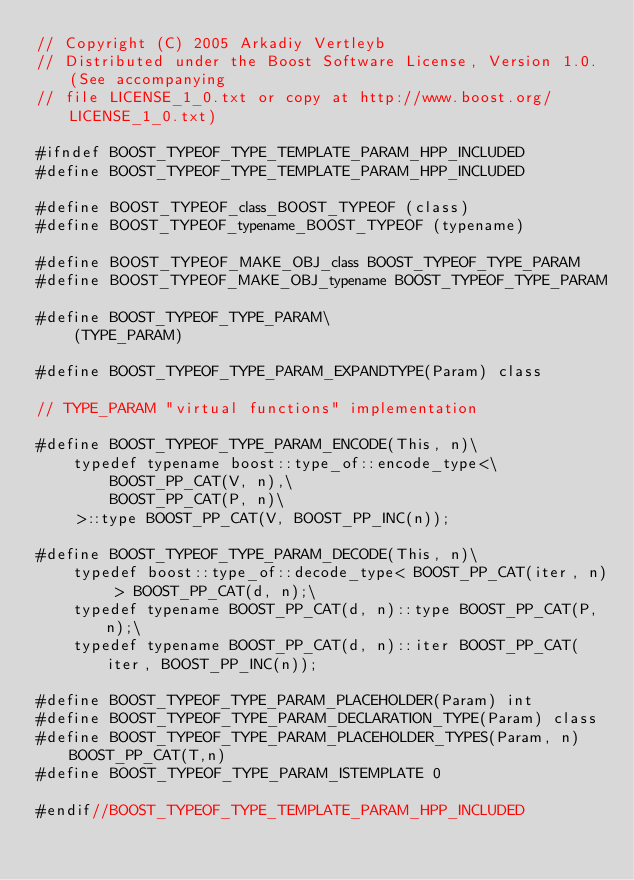<code> <loc_0><loc_0><loc_500><loc_500><_C++_>// Copyright (C) 2005 Arkadiy Vertleyb
// Distributed under the Boost Software License, Version 1.0. (See accompanying
// file LICENSE_1_0.txt or copy at http://www.boost.org/LICENSE_1_0.txt)

#ifndef BOOST_TYPEOF_TYPE_TEMPLATE_PARAM_HPP_INCLUDED
#define BOOST_TYPEOF_TYPE_TEMPLATE_PARAM_HPP_INCLUDED

#define BOOST_TYPEOF_class_BOOST_TYPEOF (class)
#define BOOST_TYPEOF_typename_BOOST_TYPEOF (typename)

#define BOOST_TYPEOF_MAKE_OBJ_class BOOST_TYPEOF_TYPE_PARAM
#define BOOST_TYPEOF_MAKE_OBJ_typename BOOST_TYPEOF_TYPE_PARAM

#define BOOST_TYPEOF_TYPE_PARAM\
    (TYPE_PARAM)

#define BOOST_TYPEOF_TYPE_PARAM_EXPANDTYPE(Param) class

// TYPE_PARAM "virtual functions" implementation

#define BOOST_TYPEOF_TYPE_PARAM_ENCODE(This, n)\
    typedef typename boost::type_of::encode_type<\
        BOOST_PP_CAT(V, n),\
        BOOST_PP_CAT(P, n)\
    >::type BOOST_PP_CAT(V, BOOST_PP_INC(n));

#define BOOST_TYPEOF_TYPE_PARAM_DECODE(This, n)\
    typedef boost::type_of::decode_type< BOOST_PP_CAT(iter, n) > BOOST_PP_CAT(d, n);\
    typedef typename BOOST_PP_CAT(d, n)::type BOOST_PP_CAT(P, n);\
    typedef typename BOOST_PP_CAT(d, n)::iter BOOST_PP_CAT(iter, BOOST_PP_INC(n));

#define BOOST_TYPEOF_TYPE_PARAM_PLACEHOLDER(Param) int
#define BOOST_TYPEOF_TYPE_PARAM_DECLARATION_TYPE(Param) class
#define BOOST_TYPEOF_TYPE_PARAM_PLACEHOLDER_TYPES(Param, n) BOOST_PP_CAT(T,n)
#define BOOST_TYPEOF_TYPE_PARAM_ISTEMPLATE 0

#endif//BOOST_TYPEOF_TYPE_TEMPLATE_PARAM_HPP_INCLUDED
</code> 